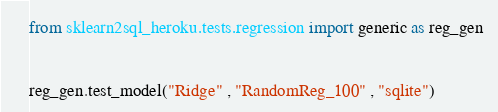<code> <loc_0><loc_0><loc_500><loc_500><_Python_>from sklearn2sql_heroku.tests.regression import generic as reg_gen


reg_gen.test_model("Ridge" , "RandomReg_100" , "sqlite")
</code> 